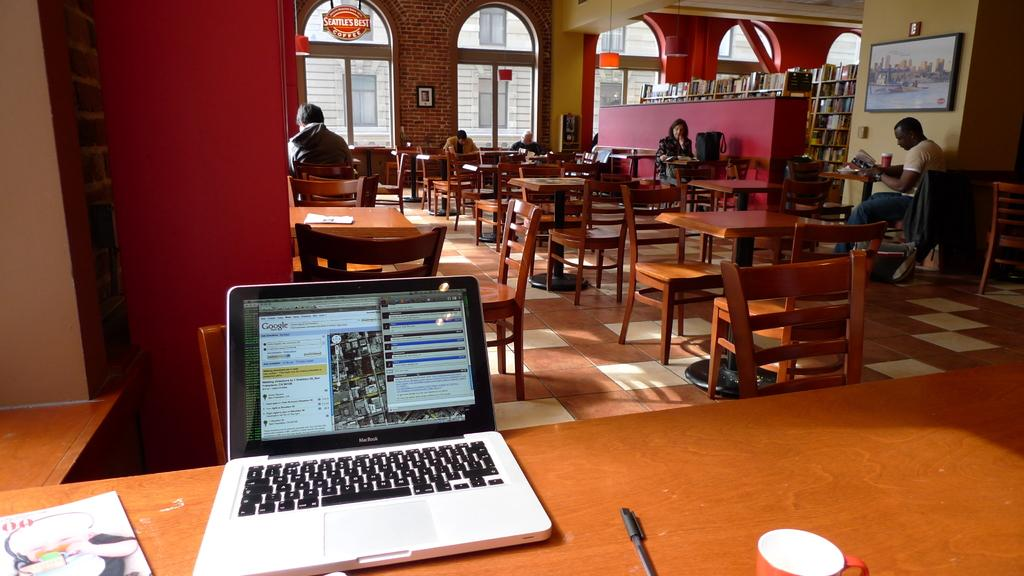What type of openings can be seen in the image? There are windows in the image. What type of structure is visible in the image? There is a wall in the image. What type of furniture is present in the image? There are tables and chairs in the image. What are the people in the image doing? There are people sitting in the image. What is located in the front of the image? There is a table in the front of the image. What items can be seen on the table in the image? There is a book, a laptop, a pen, and a cup on the table. Can you tell me how many horses are depicted in the image? There are no horses present in the image. What type of snack is being eaten by the people in the image? There is no snack, such as popcorn, visible in the image. 